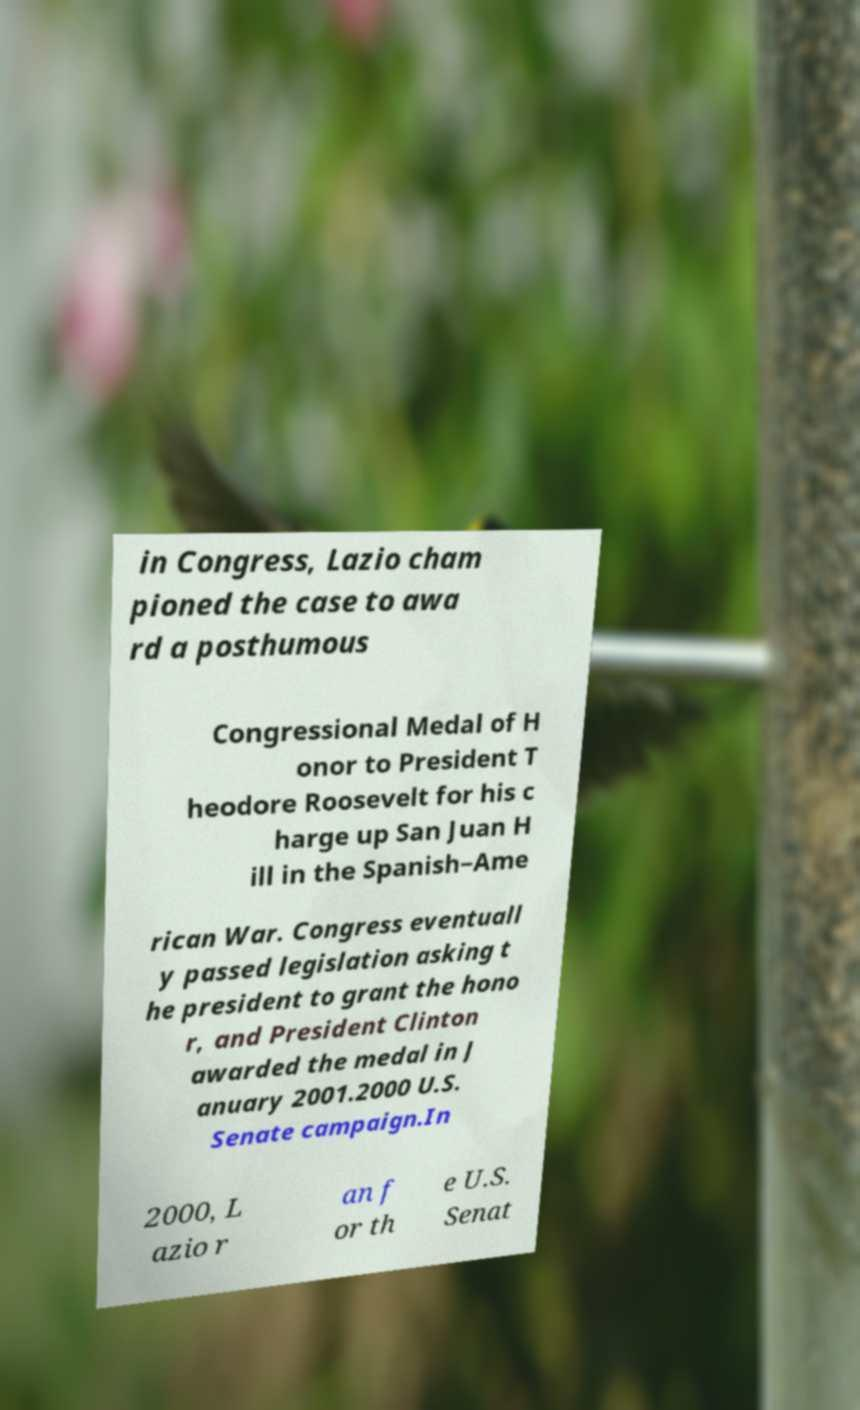Could you extract and type out the text from this image? in Congress, Lazio cham pioned the case to awa rd a posthumous Congressional Medal of H onor to President T heodore Roosevelt for his c harge up San Juan H ill in the Spanish–Ame rican War. Congress eventuall y passed legislation asking t he president to grant the hono r, and President Clinton awarded the medal in J anuary 2001.2000 U.S. Senate campaign.In 2000, L azio r an f or th e U.S. Senat 